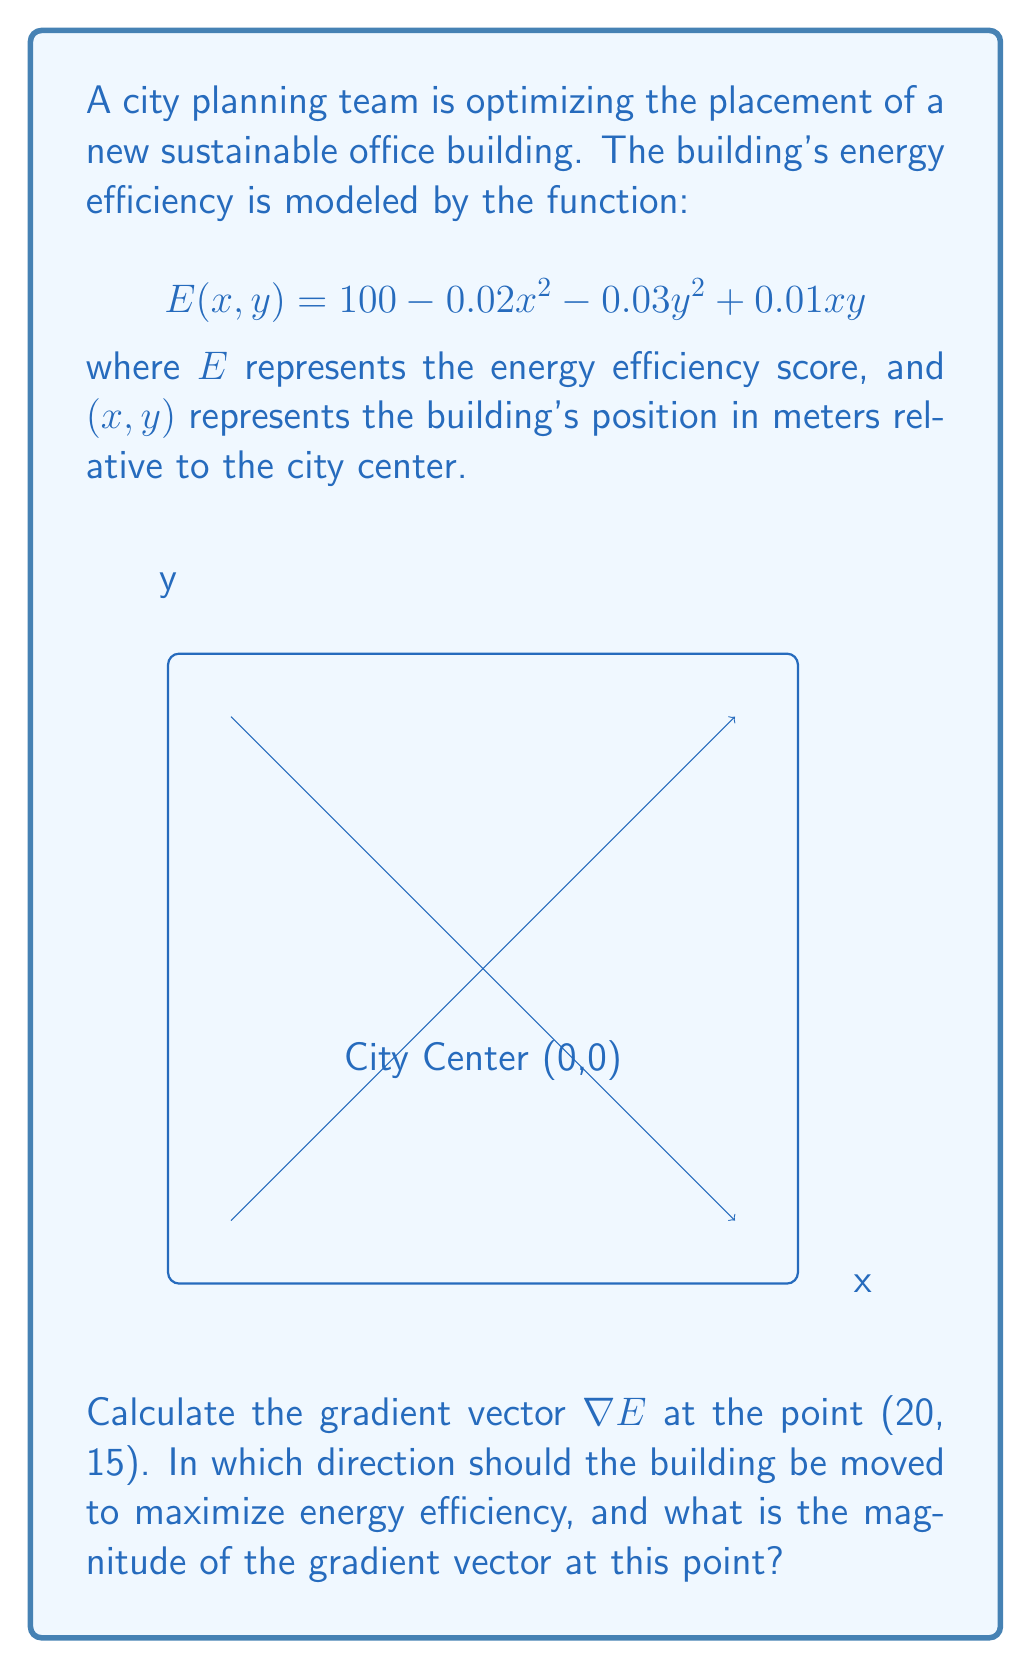Help me with this question. Let's approach this step-by-step:

1) The gradient vector $\nabla E$ is defined as:

   $$\nabla E = \left(\frac{\partial E}{\partial x}, \frac{\partial E}{\partial y}\right)$$

2) We need to calculate the partial derivatives:

   $$\frac{\partial E}{\partial x} = -0.04x + 0.01y$$
   $$\frac{\partial E}{\partial y} = -0.06y + 0.01x$$

3) Now, let's evaluate these at the point (20, 15):

   $$\frac{\partial E}{\partial x}\bigg|_{(20,15)} = -0.04(20) + 0.01(15) = -0.65$$
   $$\frac{\partial E}{\partial y}\bigg|_{(20,15)} = -0.06(15) + 0.01(20) = -0.70$$

4) Therefore, the gradient vector at (20, 15) is:

   $$\nabla E(20, 15) = (-0.65, -0.70)$$

5) The direction of steepest increase is opposite to the gradient vector. So, to maximize energy efficiency, the building should be moved in the direction:

   $$(-(-0.65), -(-0.70)) = (0.65, 0.70)$$

6) The magnitude of the gradient vector is:

   $$\|\nabla E(20, 15)\| = \sqrt{(-0.65)^2 + (-0.70)^2} = \sqrt{0.4225 + 0.49} = \sqrt{0.9125} \approx 0.9552$$

Therefore, the building should be moved in the direction (0.65, 0.70), which is towards the city center, and the magnitude of the gradient vector at this point is approximately 0.9552.
Answer: Direction: (0.65, 0.70), Magnitude: 0.9552 